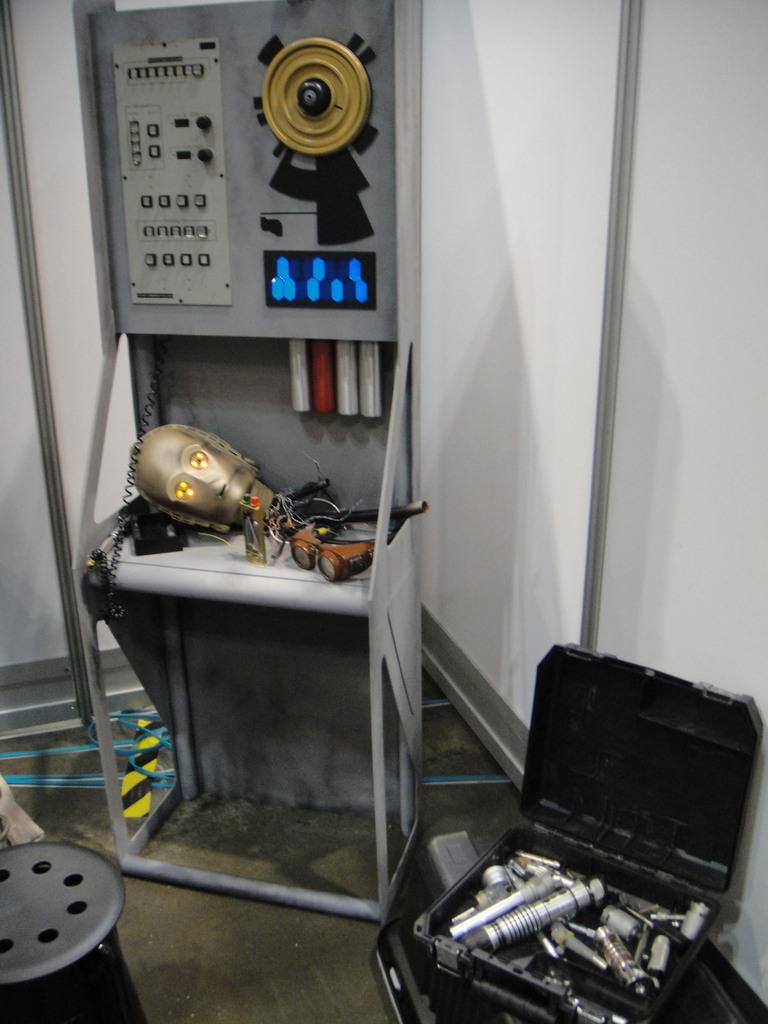What is the main object in the image? There is a machine in the image. What is placed on the machine? There are objects placed on the machine. What else can be seen in the image related to tools? There is a toolbox with tools in the image. What is on the floor in the image? There are objects on the floor in the image. What can be seen in the background of the image? There is a wall visible in the image. What type of peace symbol is present in the image? There is no peace symbol present in the image. How does the heat affect the machine in the image? The image does not provide information about the temperature or heat affecting the machine. What is the noise level in the image? The image does not provide information about the noise level in the scene. 